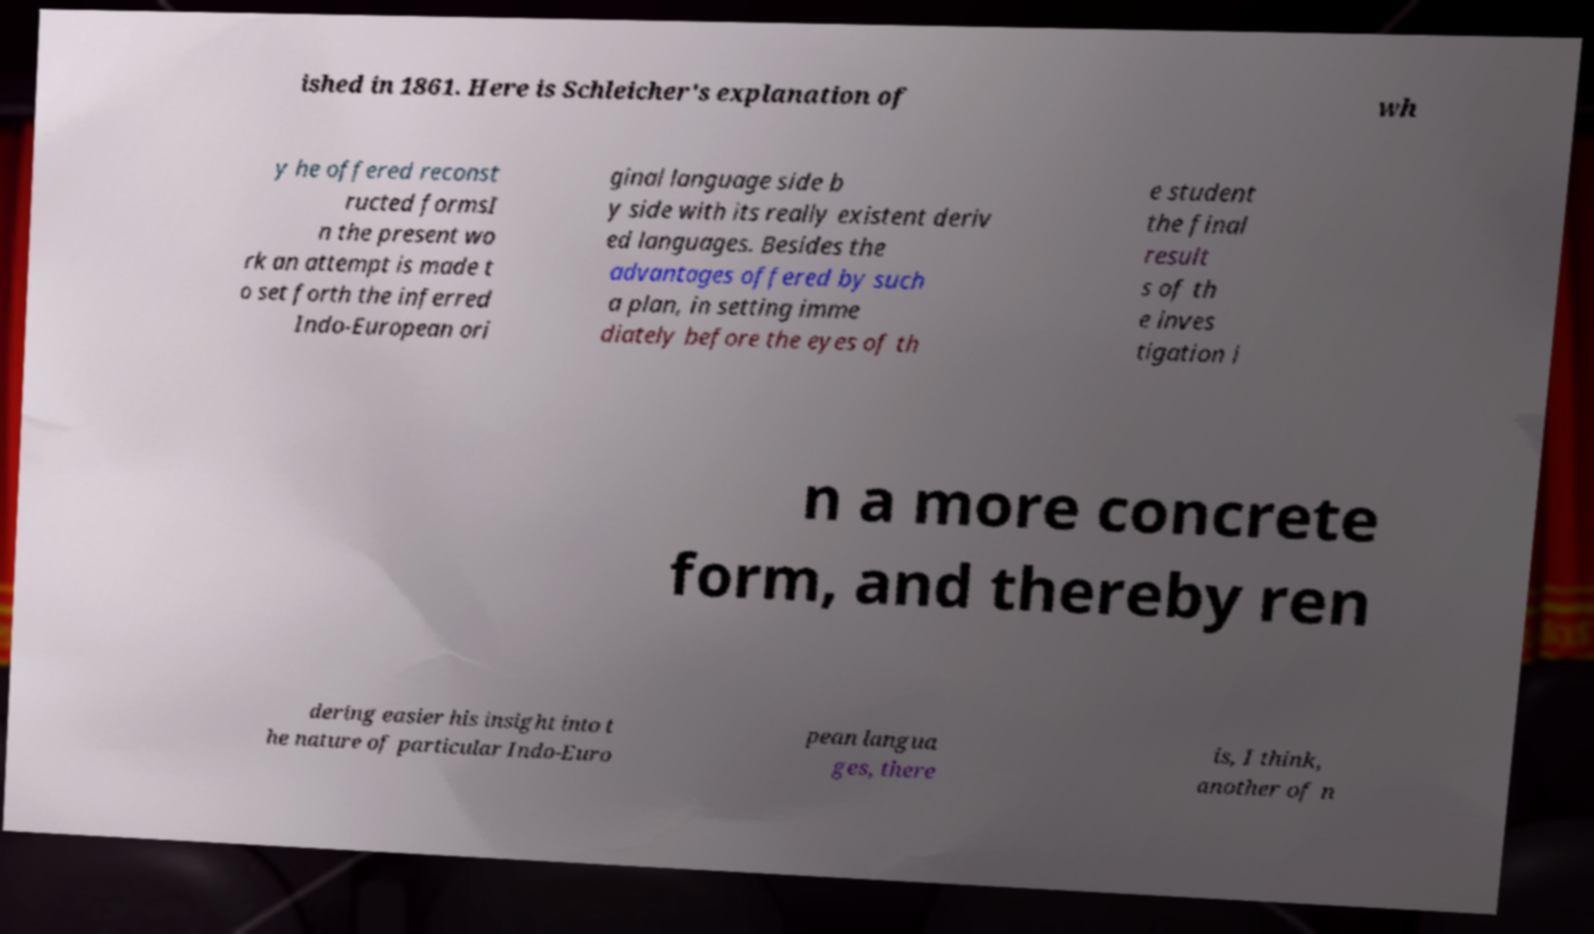Please identify and transcribe the text found in this image. ished in 1861. Here is Schleicher's explanation of wh y he offered reconst ructed formsI n the present wo rk an attempt is made t o set forth the inferred Indo-European ori ginal language side b y side with its really existent deriv ed languages. Besides the advantages offered by such a plan, in setting imme diately before the eyes of th e student the final result s of th e inves tigation i n a more concrete form, and thereby ren dering easier his insight into t he nature of particular Indo-Euro pean langua ges, there is, I think, another of n 